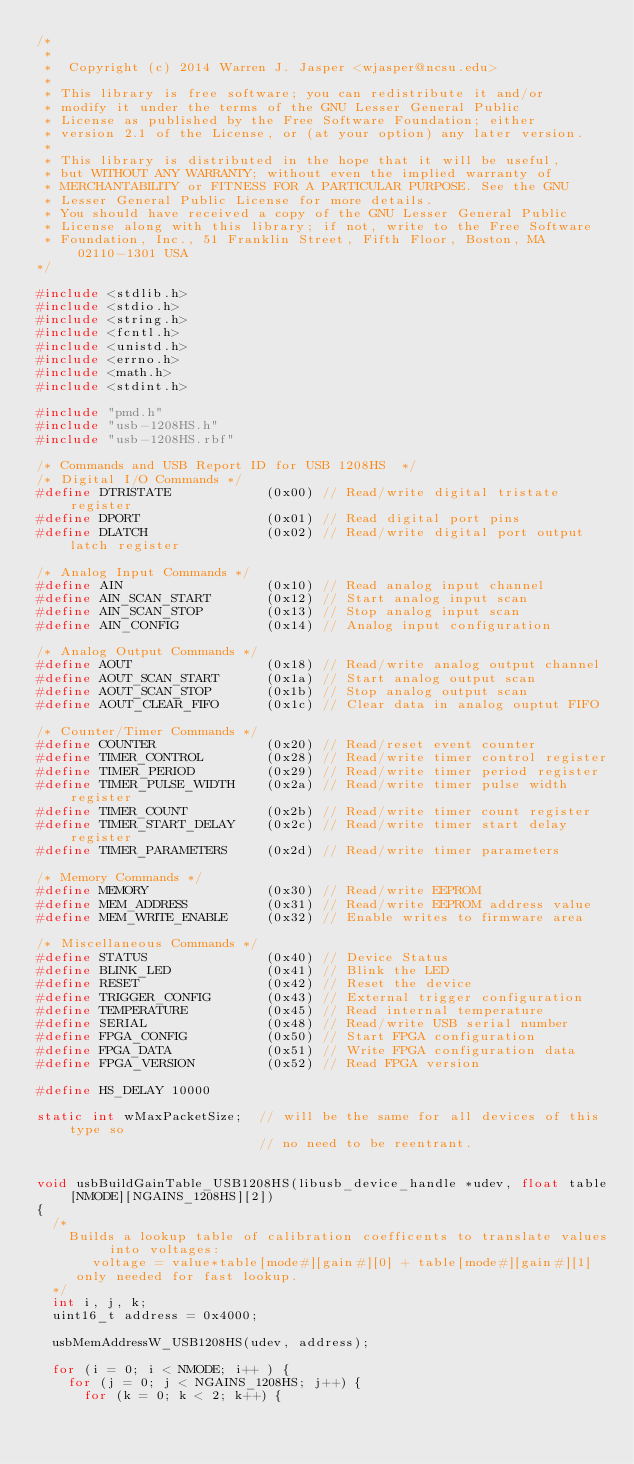Convert code to text. <code><loc_0><loc_0><loc_500><loc_500><_C_>/*
 *
 *  Copyright (c) 2014 Warren J. Jasper <wjasper@ncsu.edu>
 *
 * This library is free software; you can redistribute it and/or
 * modify it under the terms of the GNU Lesser General Public
 * License as published by the Free Software Foundation; either
 * version 2.1 of the License, or (at your option) any later version.
 *
 * This library is distributed in the hope that it will be useful,
 * but WITHOUT ANY WARRANTY; without even the implied warranty of
 * MERCHANTABILITY or FITNESS FOR A PARTICULAR PURPOSE. See the GNU
 * Lesser General Public License for more details.
 * You should have received a copy of the GNU Lesser General Public
 * License along with this library; if not, write to the Free Software
 * Foundation, Inc., 51 Franklin Street, Fifth Floor, Boston, MA 02110-1301 USA
*/

#include <stdlib.h>
#include <stdio.h>
#include <string.h>
#include <fcntl.h>
#include <unistd.h>
#include <errno.h>
#include <math.h>
#include <stdint.h>

#include "pmd.h"
#include "usb-1208HS.h"
#include "usb-1208HS.rbf"

/* Commands and USB Report ID for USB 1208HS  */
/* Digital I/O Commands */
#define DTRISTATE            (0x00) // Read/write digital tristate register
#define DPORT                (0x01) // Read digital port pins
#define DLATCH               (0x02) // Read/write digital port output latch register

/* Analog Input Commands */
#define AIN                  (0x10) // Read analog input channel
#define AIN_SCAN_START       (0x12) // Start analog input scan
#define AIN_SCAN_STOP        (0x13) // Stop analog input scan
#define AIN_CONFIG           (0x14) // Analog input configuration

/* Analog Output Commands */
#define AOUT                 (0x18) // Read/write analog output channel
#define AOUT_SCAN_START      (0x1a) // Start analog output scan
#define AOUT_SCAN_STOP       (0x1b) // Stop analog output scan
#define AOUT_CLEAR_FIFO      (0x1c) // Clear data in analog ouptut FIFO

/* Counter/Timer Commands */
#define COUNTER              (0x20) // Read/reset event counter
#define TIMER_CONTROL        (0x28) // Read/write timer control register
#define TIMER_PERIOD         (0x29) // Read/write timer period register
#define TIMER_PULSE_WIDTH    (0x2a) // Read/write timer pulse width register
#define TIMER_COUNT          (0x2b) // Read/write timer count register
#define TIMER_START_DELAY    (0x2c) // Read/write timer start delay register
#define TIMER_PARAMETERS     (0x2d) // Read/write timer parameters

/* Memory Commands */
#define MEMORY               (0x30) // Read/write EEPROM
#define MEM_ADDRESS          (0x31) // Read/write EEPROM address value
#define MEM_WRITE_ENABLE     (0x32) // Enable writes to firmware area

/* Miscellaneous Commands */
#define STATUS               (0x40) // Device Status
#define BLINK_LED            (0x41) // Blink the LED
#define RESET                (0x42) // Reset the device
#define TRIGGER_CONFIG       (0x43) // External trigger configuration
#define TEMPERATURE          (0x45) // Read internal temperature
#define SERIAL               (0x48) // Read/write USB serial number
#define FPGA_CONFIG          (0x50) // Start FPGA configuration
#define FPGA_DATA            (0x51) // Write FPGA configuration data
#define FPGA_VERSION         (0x52) // Read FPGA version

#define HS_DELAY 10000

static int wMaxPacketSize;  // will be the same for all devices of this type so
                            // no need to be reentrant. 


void usbBuildGainTable_USB1208HS(libusb_device_handle *udev, float table[NMODE][NGAINS_1208HS][2])
{
  /*
    Builds a lookup table of calibration coefficents to translate values into voltages:
       voltage = value*table[mode#][gain#][0] + table[mode#][gain#][1]
     only needed for fast lookup.
  */
  int i, j, k;
  uint16_t address = 0x4000;

  usbMemAddressW_USB1208HS(udev, address);
  
  for (i = 0; i < NMODE; i++ ) {
    for (j = 0; j < NGAINS_1208HS; j++) {
      for (k = 0; k < 2; k++) {</code> 